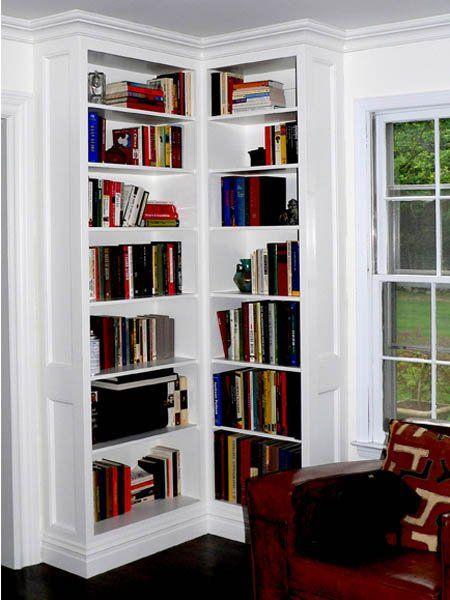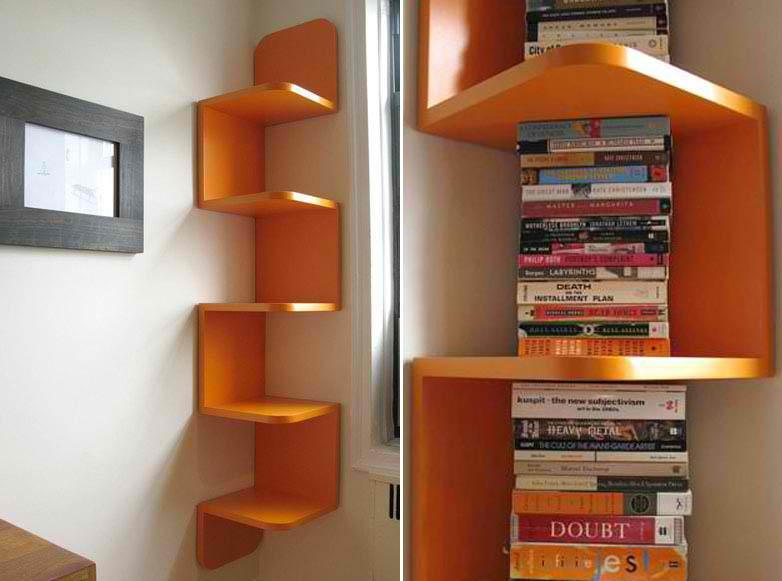The first image is the image on the left, the second image is the image on the right. Considering the images on both sides, is "An image shows a non-white corner bookshelf that includes at least some open ends" valid? Answer yes or no. Yes. The first image is the image on the left, the second image is the image on the right. Examine the images to the left and right. Is the description "The bookshelf on the right covers an entire right-angle corner." accurate? Answer yes or no. No. 